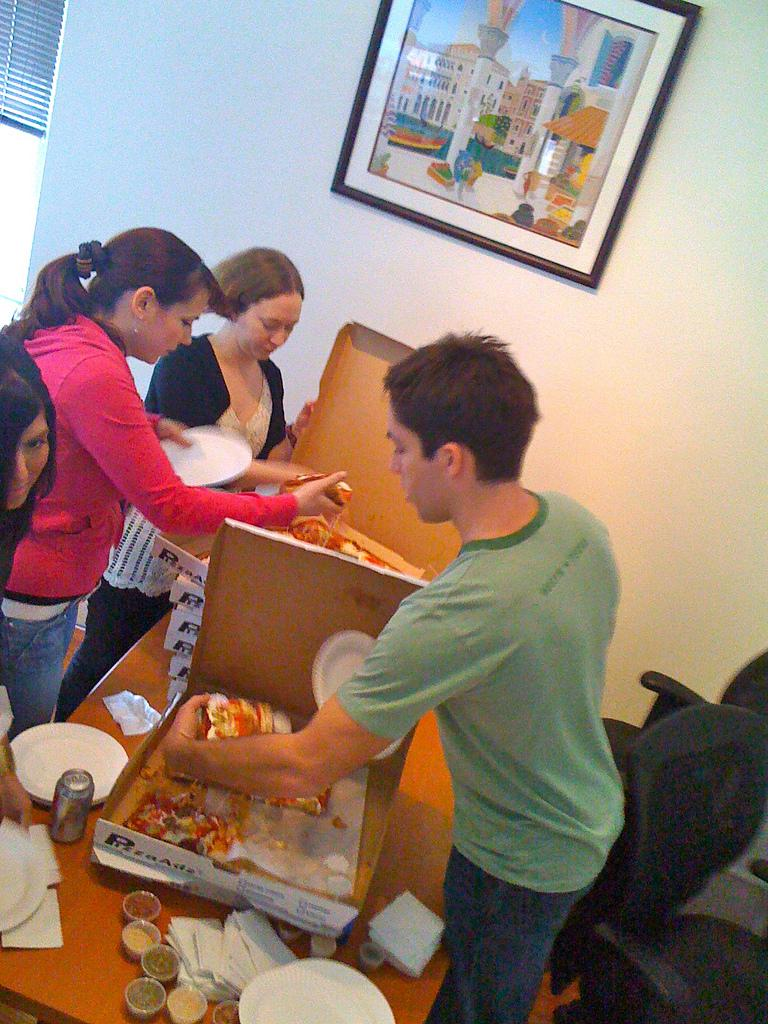Question: where does this scene appear to be?
Choices:
A. At a church.
B. At a workplace.
C. At a ballroom.
D. At a museum .
Answer with the letter. Answer: B Question: how many people are at the table?
Choices:
A. Three women and one man.
B. Two women and two babies.
C. Two men and one boy.
D. A woman and one girl.
Answer with the letter. Answer: A Question: where is the oregano, parmesan and hot chili peppers?
Choices:
A. On the counter.
B. On the table.
C. On stove.
D. On the rack.
Answer with the letter. Answer: B Question: who is in the picture?
Choices:
A. 2 cats.
B. Our neighbors.
C. The kids who live nextdoor.
D. Three girls and one boy.
Answer with the letter. Answer: D Question: when will the people eat?
Choices:
A. After they get their food.
B. After grace has been said.
C. When the chores are done.
D. After everyone gets here.
Answer with the letter. Answer: A Question: what color is the boy's shirt?
Choices:
A. Red.
B. Blue.
C. Orange.
D. It is green.
Answer with the letter. Answer: D Question: what color is the boys pants?
Choices:
A. They are blue.
B. Black.
C. Brown.
D. White.
Answer with the letter. Answer: A Question: what are the people going to eat?
Choices:
A. Pizza.
B. Hamburgers.
C. Hotdogs.
D. Tacos.
Answer with the letter. Answer: A Question: where did they get the pizza?
Choices:
A. From the boxes.
B. From the pizzeria.
C. From the pizzy guy.
D. From the neighbors.
Answer with the letter. Answer: A Question: how many people are in the picture?
Choices:
A. Four people.
B. One.
C. Two.
D. Three.
Answer with the letter. Answer: A Question: why are the people getting food?
Choices:
A. Someone else is hungry.
B. They are hungry.
C. They're getting it for later.
D. They're getting it for a party.
Answer with the letter. Answer: B Question: what is the woman in pink with a ponytail holding?
Choices:
A. A plate.
B. A cup.
C. A book.
D. A casarole.
Answer with the letter. Answer: A Question: what is on the wooden desk?
Choices:
A. A computer.
B. A soda.
C. Two open cardboard boxes of pizza.
D. Chinese take-out boxes.
Answer with the letter. Answer: C Question: how many women are lined up on the left side of the table?
Choices:
A. Three.
B. Two.
C. Four.
D. Five.
Answer with the letter. Answer: A Question: what side of the table is the man standing on?
Choices:
A. The rear side.
B. The front side.
C. The left side.
D. The right side.
Answer with the letter. Answer: D Question: what is near box of pizza?
Choices:
A. Bag of napkins.
B. Box of silverware.
C. Can of soda.
D. Sauce.
Answer with the letter. Answer: C Question: what are the people eating?
Choices:
A. Hamburgers.
B. Corndogs.
C. Pizza.
D. Hot dogs.
Answer with the letter. Answer: C 